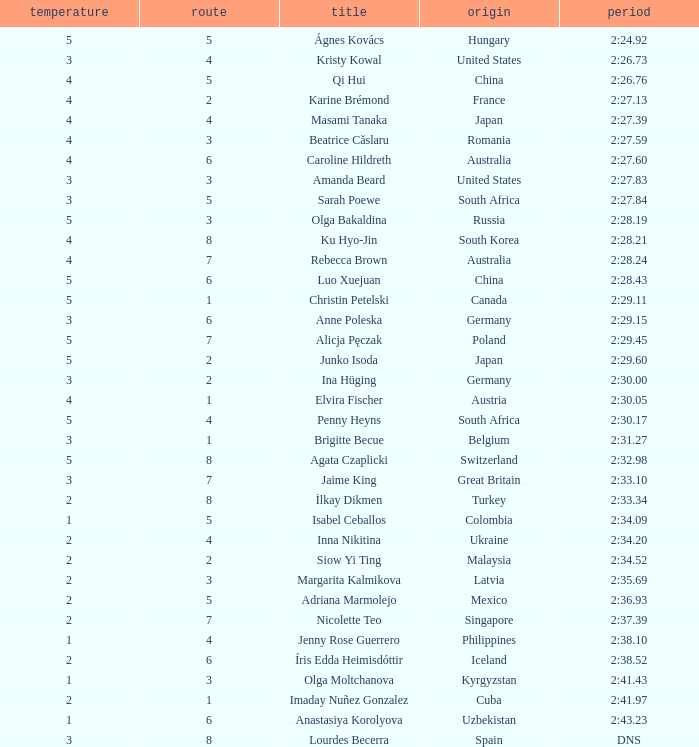Which name is related to observing 4 heats and being in a lane above 7? Ku Hyo-Jin. 